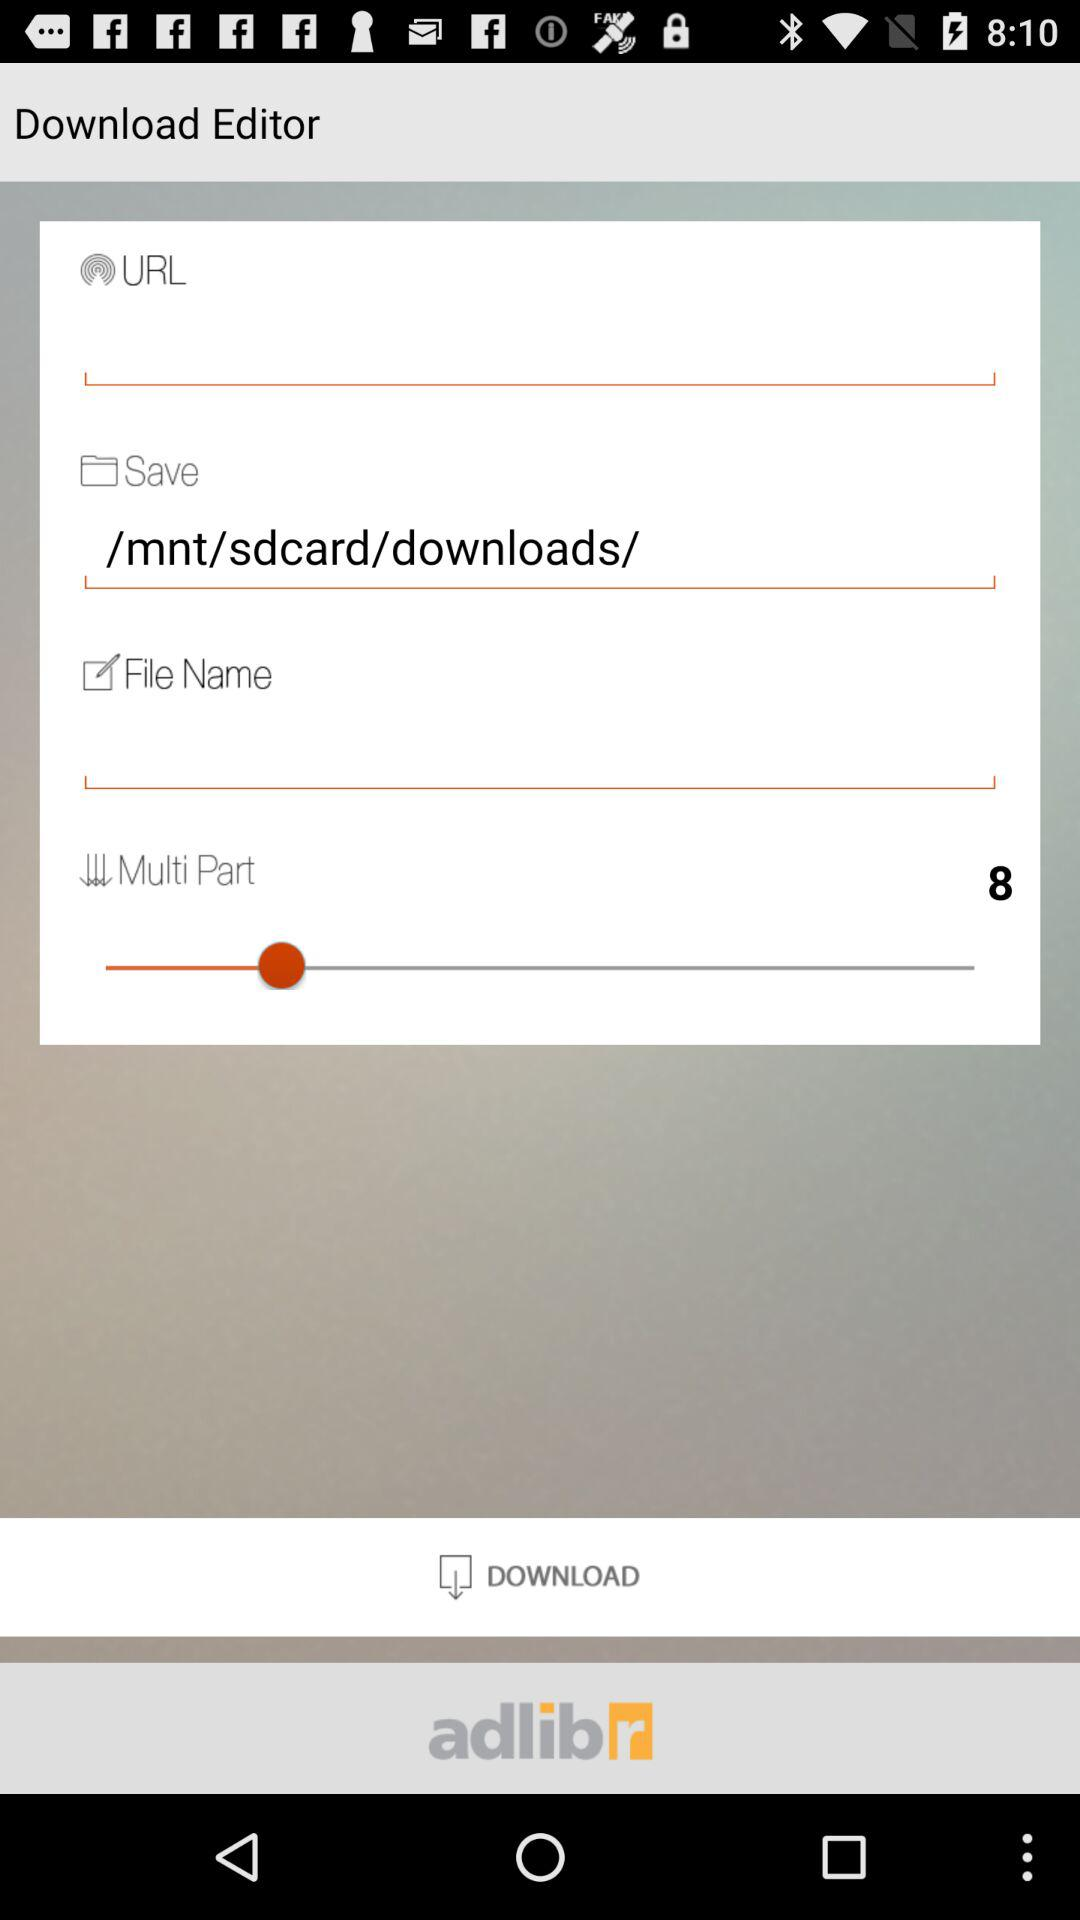Where can we save the file? The file can be saved to /mnt/sdcard/downloads/. 